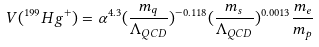<formula> <loc_0><loc_0><loc_500><loc_500>V ( ^ { 1 9 9 } H g ^ { + } ) = \alpha ^ { 4 . 3 } ( \frac { m _ { q } } { \Lambda _ { Q C D } } ) ^ { - 0 . 1 1 8 } ( \frac { m _ { s } } { \Lambda _ { Q C D } } ) ^ { 0 . 0 0 1 3 } \frac { m _ { e } } { m _ { p } }</formula> 